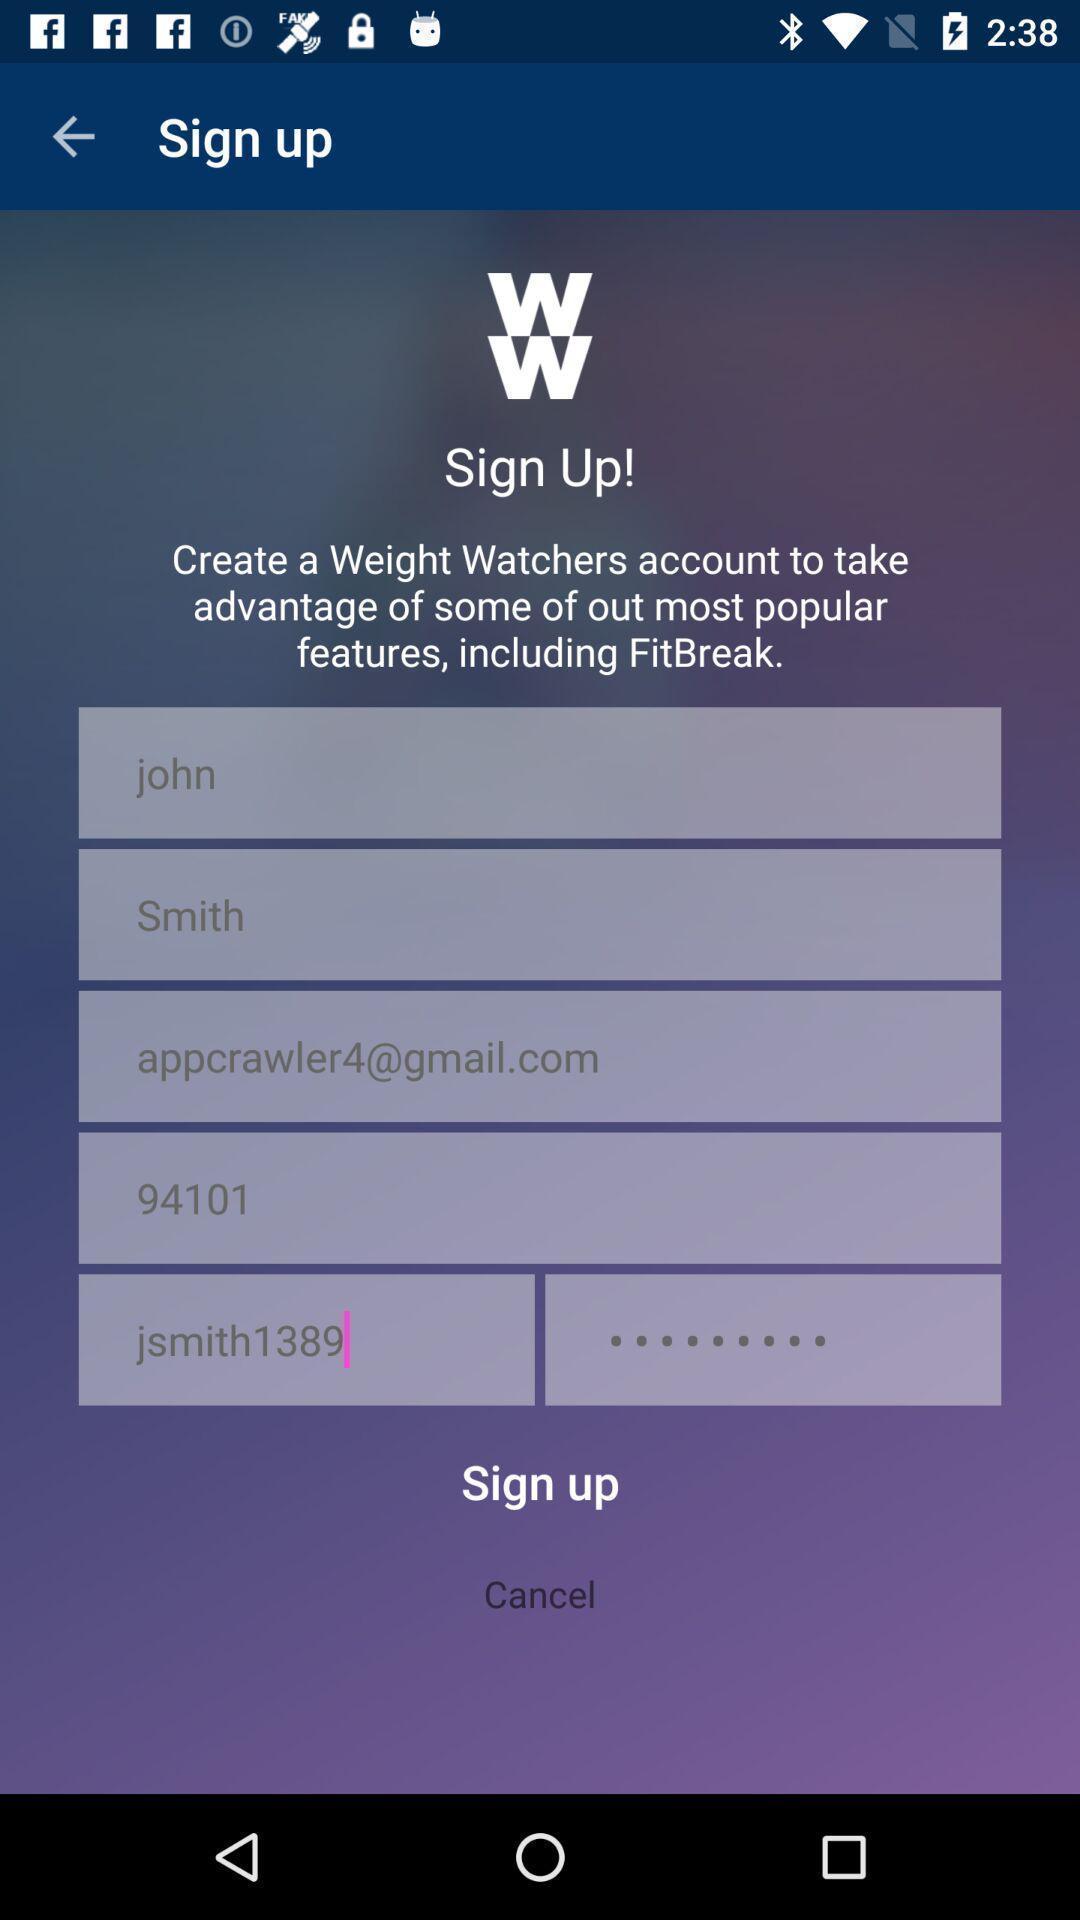Describe the visual elements of this screenshot. Sign up page of a new app. 